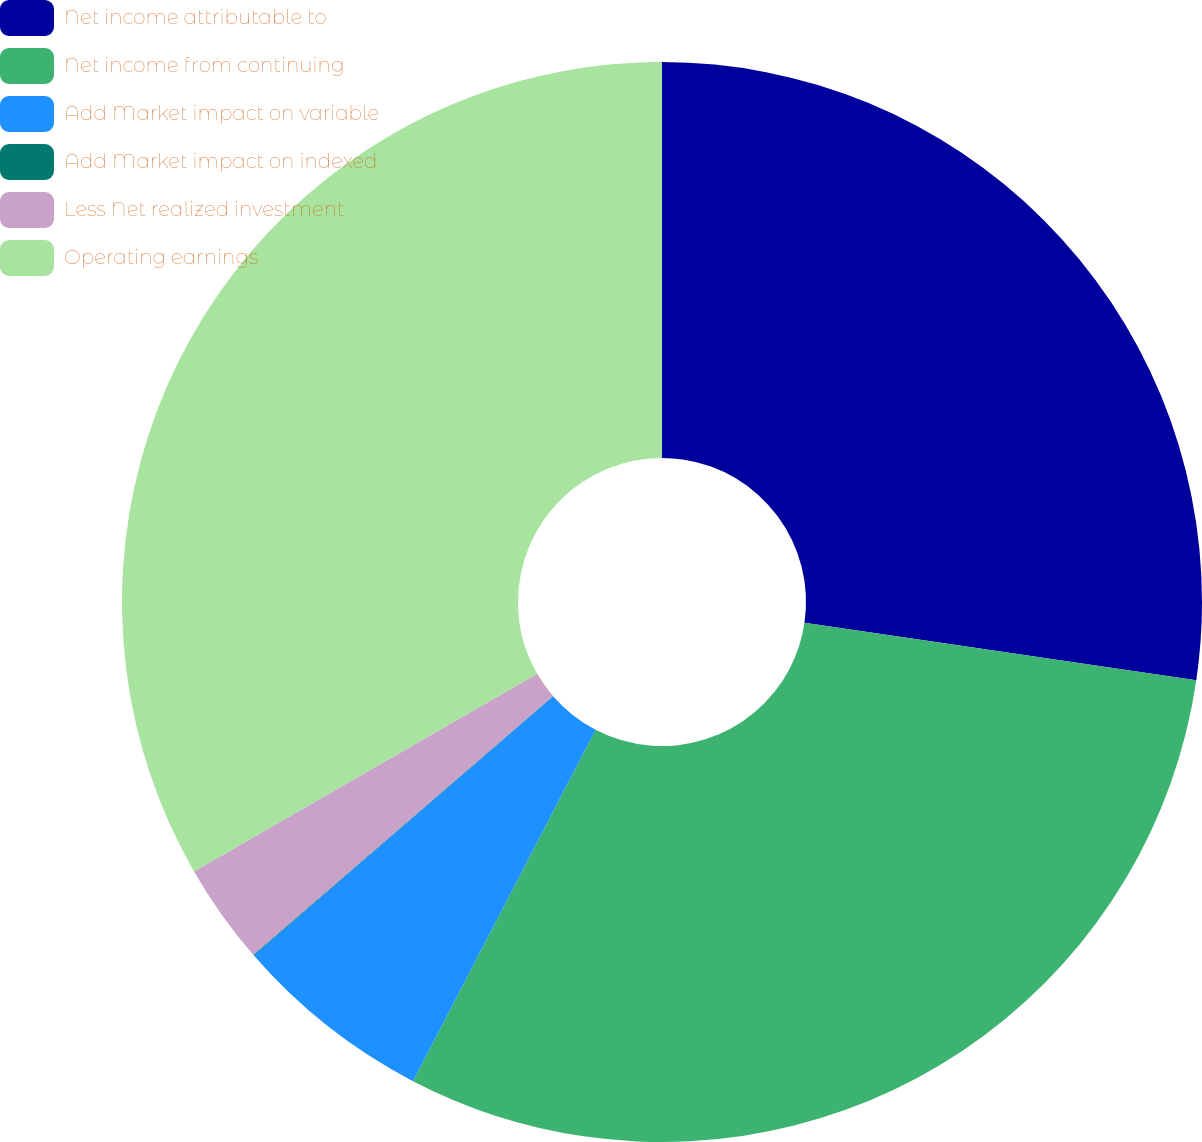Convert chart to OTSL. <chart><loc_0><loc_0><loc_500><loc_500><pie_chart><fcel>Net income attributable to<fcel>Net income from continuing<fcel>Add Market impact on variable<fcel>Add Market impact on indexed<fcel>Less Net realized investment<fcel>Operating earnings<nl><fcel>27.32%<fcel>30.32%<fcel>6.02%<fcel>0.02%<fcel>3.02%<fcel>33.32%<nl></chart> 